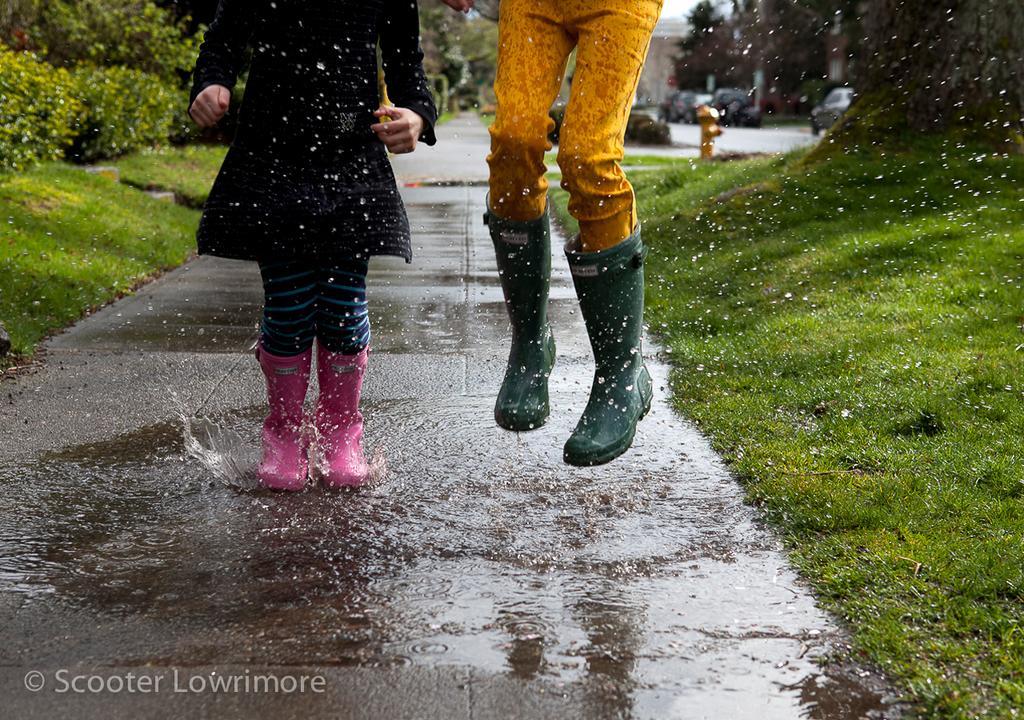Can you describe this image briefly? In the middle of the image a person is standing in the water and a person is jumping. Behind them there is grass, plants, vehicles and trees. 